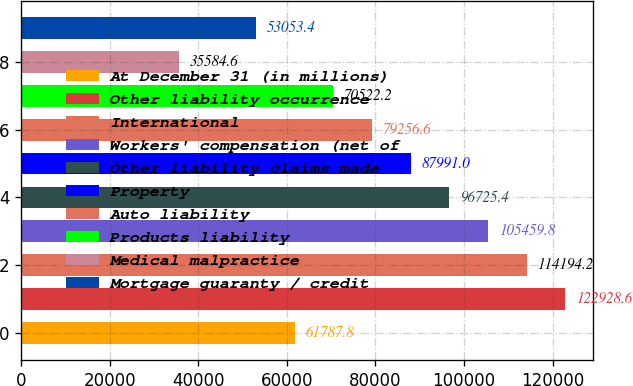Convert chart to OTSL. <chart><loc_0><loc_0><loc_500><loc_500><bar_chart><fcel>At December 31 (in millions)<fcel>Other liability occurrence<fcel>International<fcel>Workers' compensation (net of<fcel>Other liability claims made<fcel>Property<fcel>Auto liability<fcel>Products liability<fcel>Medical malpractice<fcel>Mortgage guaranty / credit<nl><fcel>61787.8<fcel>122929<fcel>114194<fcel>105460<fcel>96725.4<fcel>87991<fcel>79256.6<fcel>70522.2<fcel>35584.6<fcel>53053.4<nl></chart> 